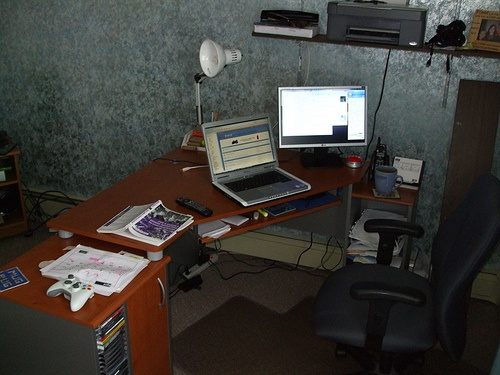Describe the objects in this image and their specific colors. I can see chair in purple, black, gray, darkgreen, and darkblue tones, laptop in purple, black, gray, and darkgray tones, book in purple, gray, darkgray, black, and lightgray tones, keyboard in purple, black, gray, and darkgray tones, and remote in purple, darkgray, lightgray, gray, and black tones in this image. 